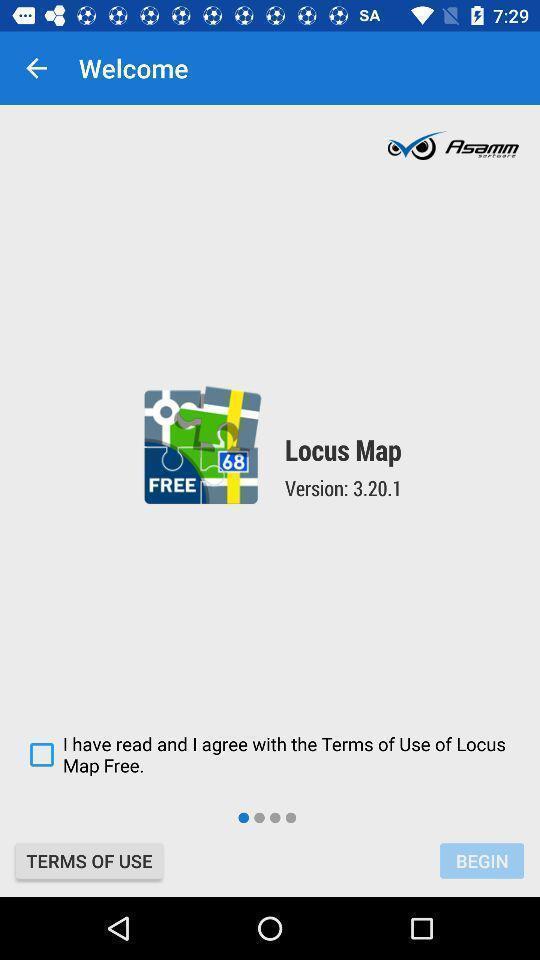Summarize the main components in this picture. Welcome page for a navigation app. 